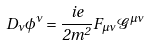Convert formula to latex. <formula><loc_0><loc_0><loc_500><loc_500>D _ { \nu } \phi ^ { \nu } = \frac { i e } { 2 m ^ { 2 } } F _ { \mu \nu } \mathcal { G } ^ { \mu \nu }</formula> 